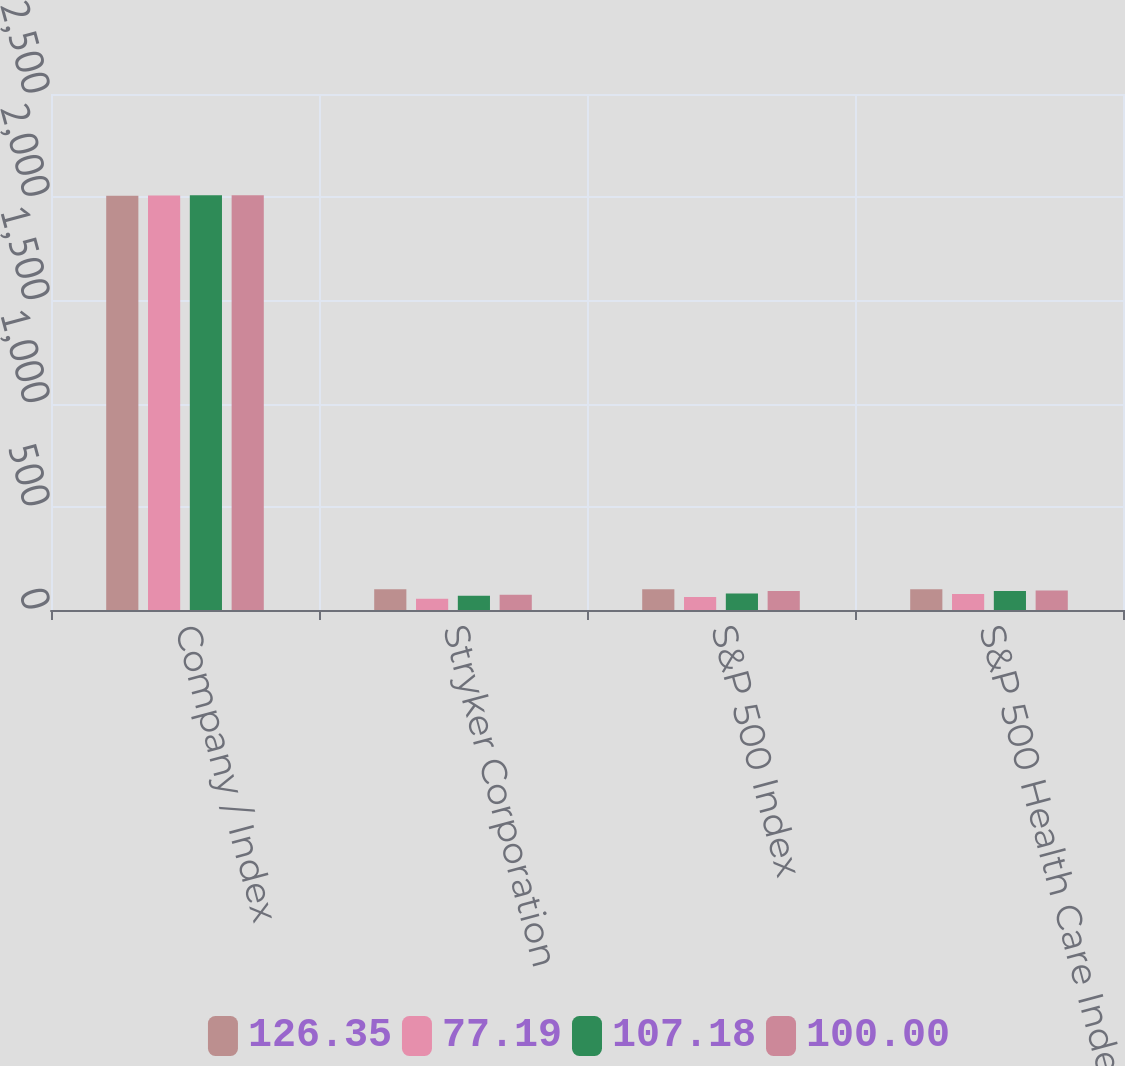<chart> <loc_0><loc_0><loc_500><loc_500><stacked_bar_chart><ecel><fcel>Company / Index<fcel>Stryker Corporation<fcel>S&P 500 Index<fcel>S&P 500 Health Care Index<nl><fcel>126.35<fcel>2007<fcel>100<fcel>100<fcel>100<nl><fcel>77.19<fcel>2008<fcel>54.01<fcel>63<fcel>77.19<nl><fcel>107.18<fcel>2009<fcel>68.44<fcel>79.68<fcel>92.4<nl><fcel>100<fcel>2010<fcel>73.84<fcel>91.68<fcel>95.08<nl></chart> 